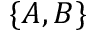<formula> <loc_0><loc_0><loc_500><loc_500>\{ A , B \}</formula> 